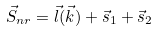<formula> <loc_0><loc_0><loc_500><loc_500>\vec { S } _ { n r } = \vec { l } ( \vec { k } ) + \vec { s } _ { 1 } + \vec { s } _ { 2 }</formula> 